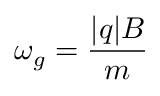<formula> <loc_0><loc_0><loc_500><loc_500>\omega _ { g } = { \frac { | q | B } { m } }</formula> 